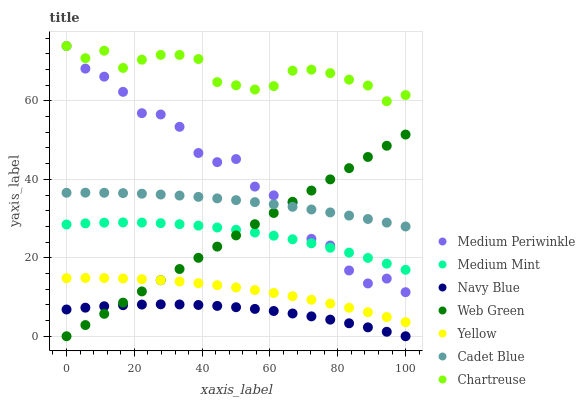Does Navy Blue have the minimum area under the curve?
Answer yes or no. Yes. Does Chartreuse have the maximum area under the curve?
Answer yes or no. Yes. Does Cadet Blue have the minimum area under the curve?
Answer yes or no. No. Does Cadet Blue have the maximum area under the curve?
Answer yes or no. No. Is Web Green the smoothest?
Answer yes or no. Yes. Is Medium Periwinkle the roughest?
Answer yes or no. Yes. Is Cadet Blue the smoothest?
Answer yes or no. No. Is Cadet Blue the roughest?
Answer yes or no. No. Does Navy Blue have the lowest value?
Answer yes or no. Yes. Does Cadet Blue have the lowest value?
Answer yes or no. No. Does Chartreuse have the highest value?
Answer yes or no. Yes. Does Cadet Blue have the highest value?
Answer yes or no. No. Is Navy Blue less than Chartreuse?
Answer yes or no. Yes. Is Cadet Blue greater than Navy Blue?
Answer yes or no. Yes. Does Medium Periwinkle intersect Web Green?
Answer yes or no. Yes. Is Medium Periwinkle less than Web Green?
Answer yes or no. No. Is Medium Periwinkle greater than Web Green?
Answer yes or no. No. Does Navy Blue intersect Chartreuse?
Answer yes or no. No. 